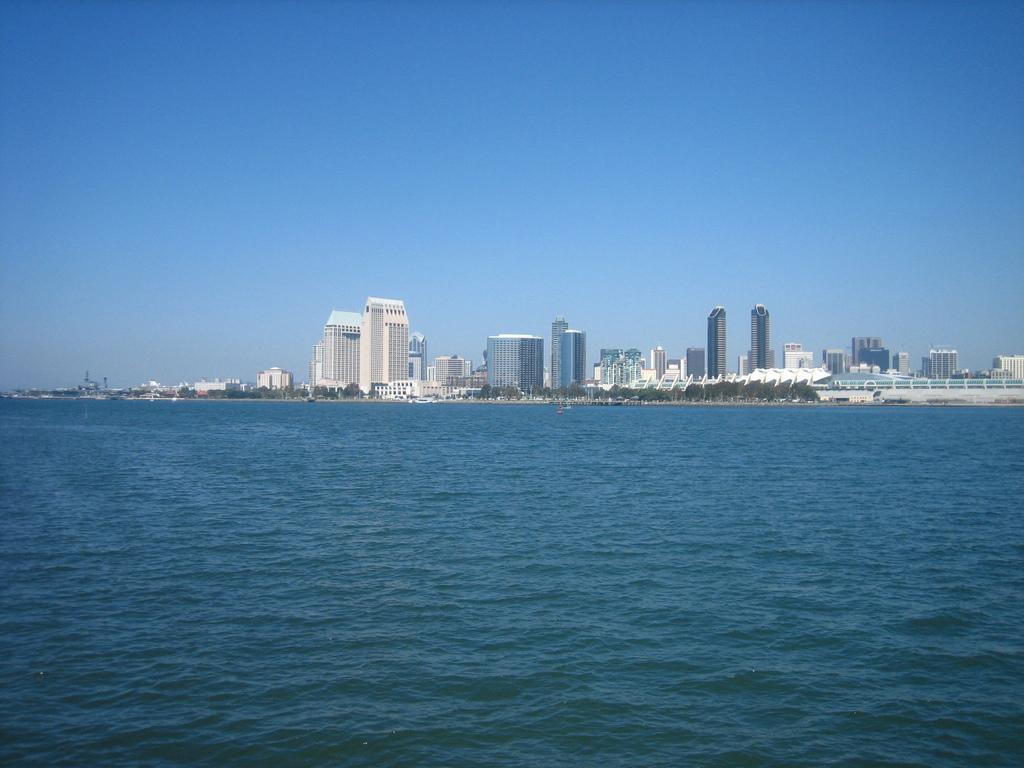Describe this image in one or two sentences. These are the skyscrapers and the buildings. I can see the trees. I think this is the sea with the water flowing. Here is the sky. 